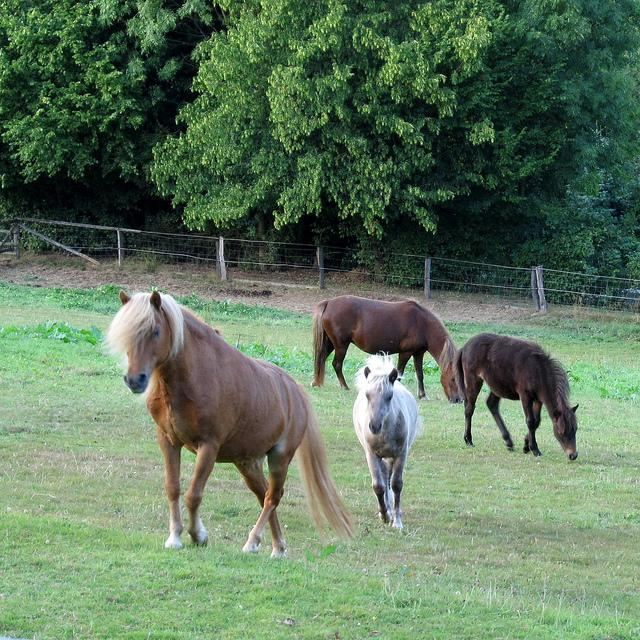What animals are present?

Choices:
A) goat
B) sheep
C) cow
D) horse horse 